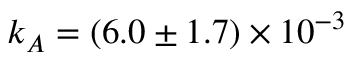<formula> <loc_0><loc_0><loc_500><loc_500>k _ { A } = ( 6 . 0 \pm 1 . 7 ) \times 1 0 ^ { - 3 }</formula> 